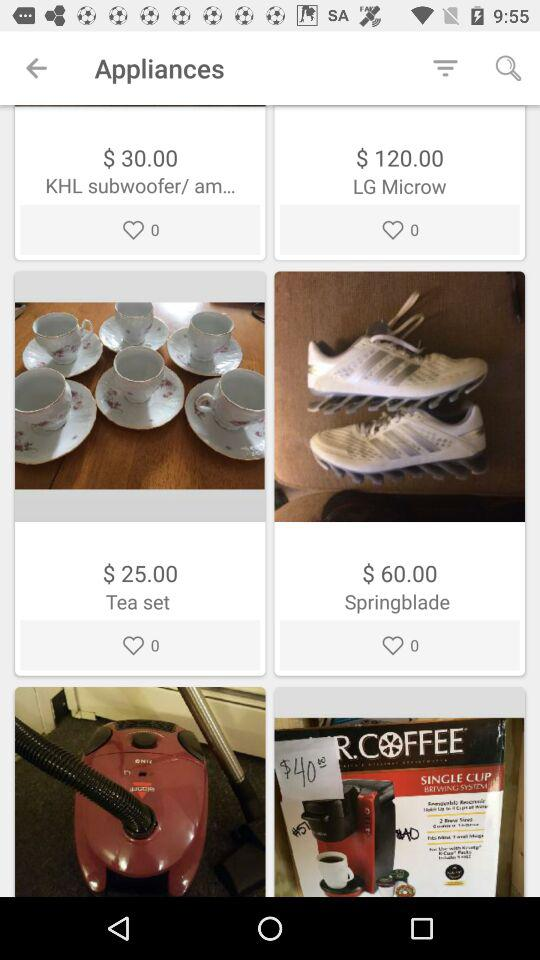How many reviews does the tea set have?
When the provided information is insufficient, respond with <no answer>. <no answer> 